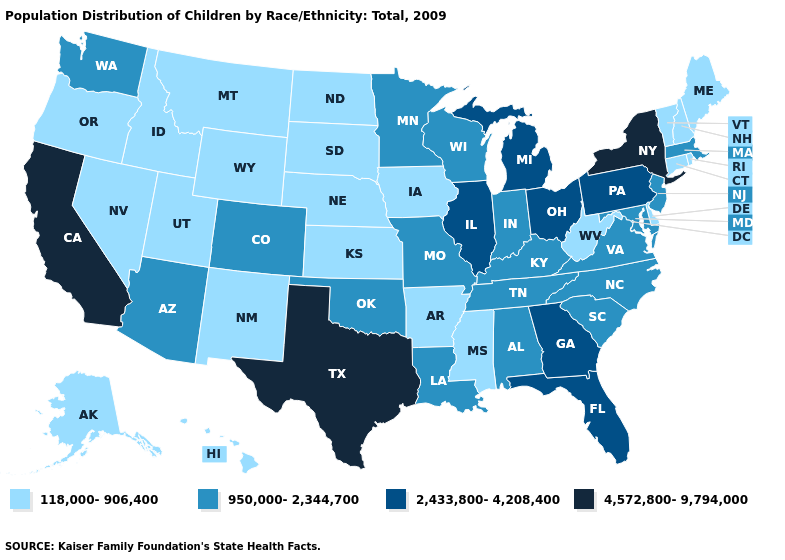Which states hav the highest value in the South?
Write a very short answer. Texas. Name the states that have a value in the range 950,000-2,344,700?
Answer briefly. Alabama, Arizona, Colorado, Indiana, Kentucky, Louisiana, Maryland, Massachusetts, Minnesota, Missouri, New Jersey, North Carolina, Oklahoma, South Carolina, Tennessee, Virginia, Washington, Wisconsin. Which states hav the highest value in the South?
Answer briefly. Texas. Does South Dakota have the lowest value in the USA?
Give a very brief answer. Yes. What is the value of New Mexico?
Write a very short answer. 118,000-906,400. What is the highest value in states that border South Carolina?
Answer briefly. 2,433,800-4,208,400. Among the states that border Delaware , does Pennsylvania have the lowest value?
Short answer required. No. What is the lowest value in the Northeast?
Write a very short answer. 118,000-906,400. Name the states that have a value in the range 118,000-906,400?
Give a very brief answer. Alaska, Arkansas, Connecticut, Delaware, Hawaii, Idaho, Iowa, Kansas, Maine, Mississippi, Montana, Nebraska, Nevada, New Hampshire, New Mexico, North Dakota, Oregon, Rhode Island, South Dakota, Utah, Vermont, West Virginia, Wyoming. Does New York have the highest value in the USA?
Quick response, please. Yes. What is the value of New York?
Keep it brief. 4,572,800-9,794,000. Does Michigan have the same value as Illinois?
Keep it brief. Yes. What is the value of Massachusetts?
Answer briefly. 950,000-2,344,700. What is the lowest value in the Northeast?
Answer briefly. 118,000-906,400. What is the highest value in the South ?
Concise answer only. 4,572,800-9,794,000. 